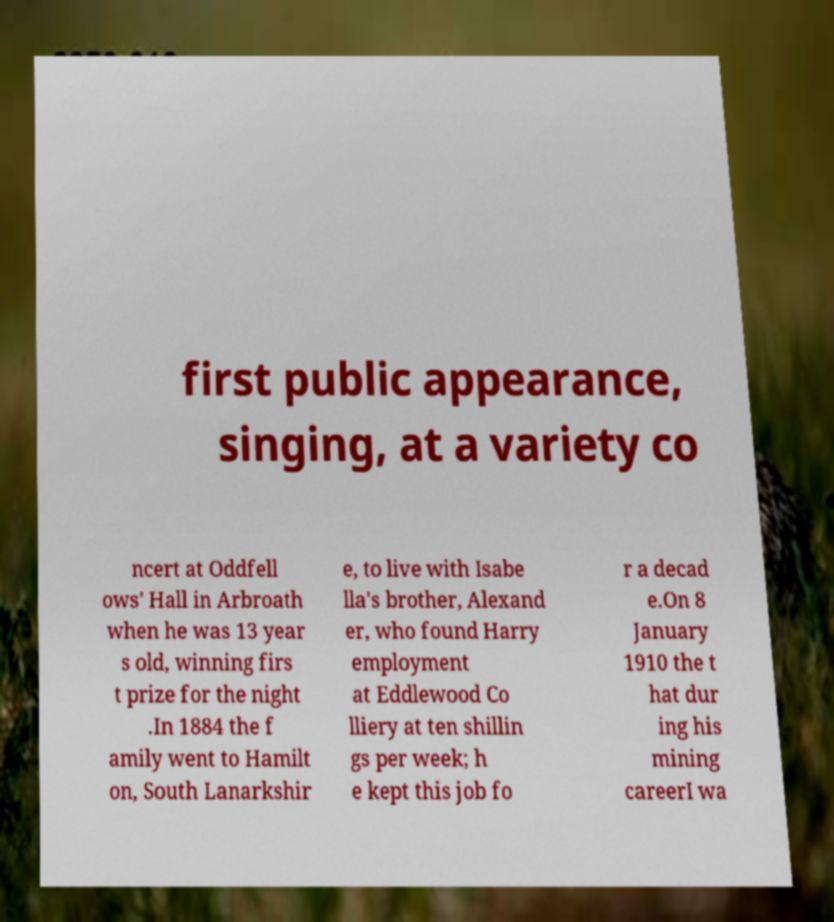Can you read and provide the text displayed in the image?This photo seems to have some interesting text. Can you extract and type it out for me? first public appearance, singing, at a variety co ncert at Oddfell ows' Hall in Arbroath when he was 13 year s old, winning firs t prize for the night .In 1884 the f amily went to Hamilt on, South Lanarkshir e, to live with Isabe lla's brother, Alexand er, who found Harry employment at Eddlewood Co lliery at ten shillin gs per week; h e kept this job fo r a decad e.On 8 January 1910 the t hat dur ing his mining careerI wa 